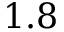Convert formula to latex. <formula><loc_0><loc_0><loc_500><loc_500>1 . 8</formula> 